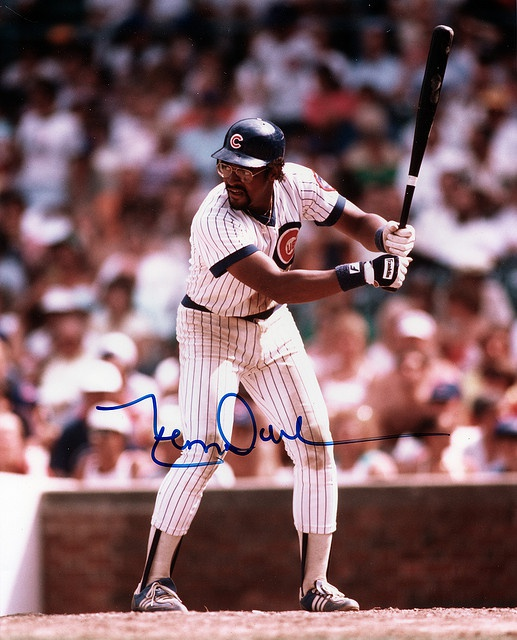Describe the objects in this image and their specific colors. I can see people in black, maroon, gray, and brown tones, people in black, lavender, lightpink, and maroon tones, people in black, darkgray, and gray tones, people in black, lightgray, brown, maroon, and lightpink tones, and people in black, lavender, brown, lightpink, and pink tones in this image. 